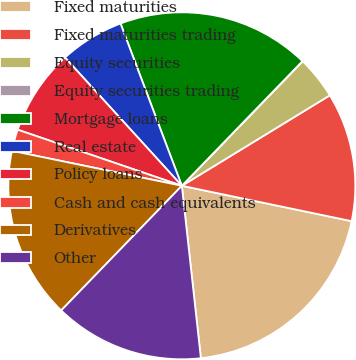Convert chart. <chart><loc_0><loc_0><loc_500><loc_500><pie_chart><fcel>Fixed maturities<fcel>Fixed maturities trading<fcel>Equity securities<fcel>Equity securities trading<fcel>Mortgage loans<fcel>Real estate<fcel>Policy loans<fcel>Cash and cash equivalents<fcel>Derivatives<fcel>Other<nl><fcel>19.98%<fcel>12.0%<fcel>4.01%<fcel>0.02%<fcel>17.99%<fcel>6.01%<fcel>8.0%<fcel>2.01%<fcel>15.99%<fcel>13.99%<nl></chart> 